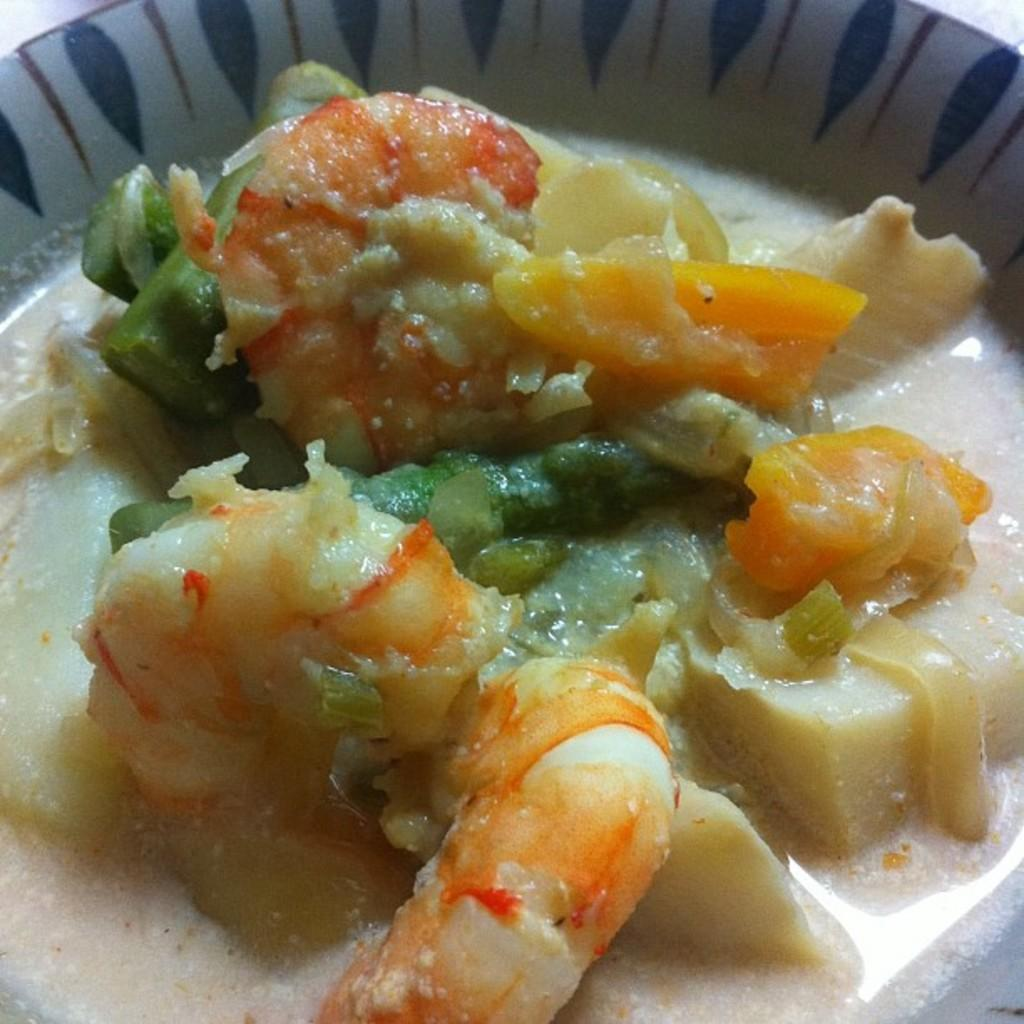What is present on the plate in the image? There is colorful food on the plate. Can you describe the food on the plate? The food on the plate is colorful. What type of pencil can be seen drawing on the plate in the image? There is no pencil present in the image, and therefore no such activity can be observed. 